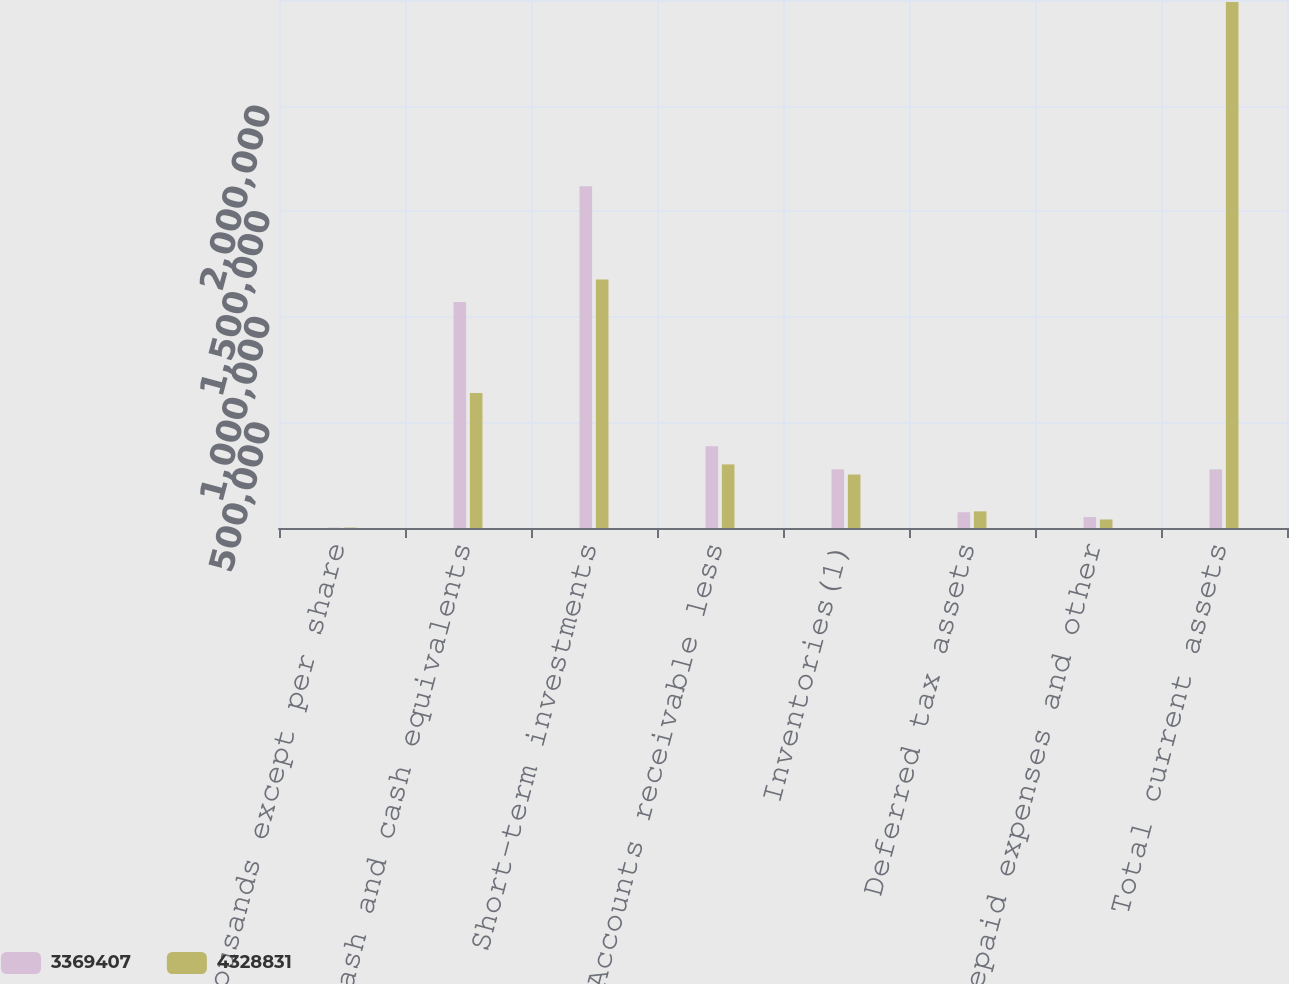Convert chart. <chart><loc_0><loc_0><loc_500><loc_500><stacked_bar_chart><ecel><fcel>(thousands except per share<fcel>Cash and cash equivalents<fcel>Short-term investments<fcel>Accounts receivable less<fcel>Inventories(1)<fcel>Deferred tax assets<fcel>Prepaid expenses and other<fcel>Total current assets<nl><fcel>3.36941e+06<fcel>2010<fcel>1.07e+06<fcel>1.61777e+06<fcel>387169<fcel>277478<fcel>74710<fcel>51874<fcel>277478<nl><fcel>4.32883e+06<fcel>2009<fcel>639729<fcel>1.17624e+06<fcel>301036<fcel>253161<fcel>78740<fcel>40363<fcel>2.49064e+06<nl></chart> 